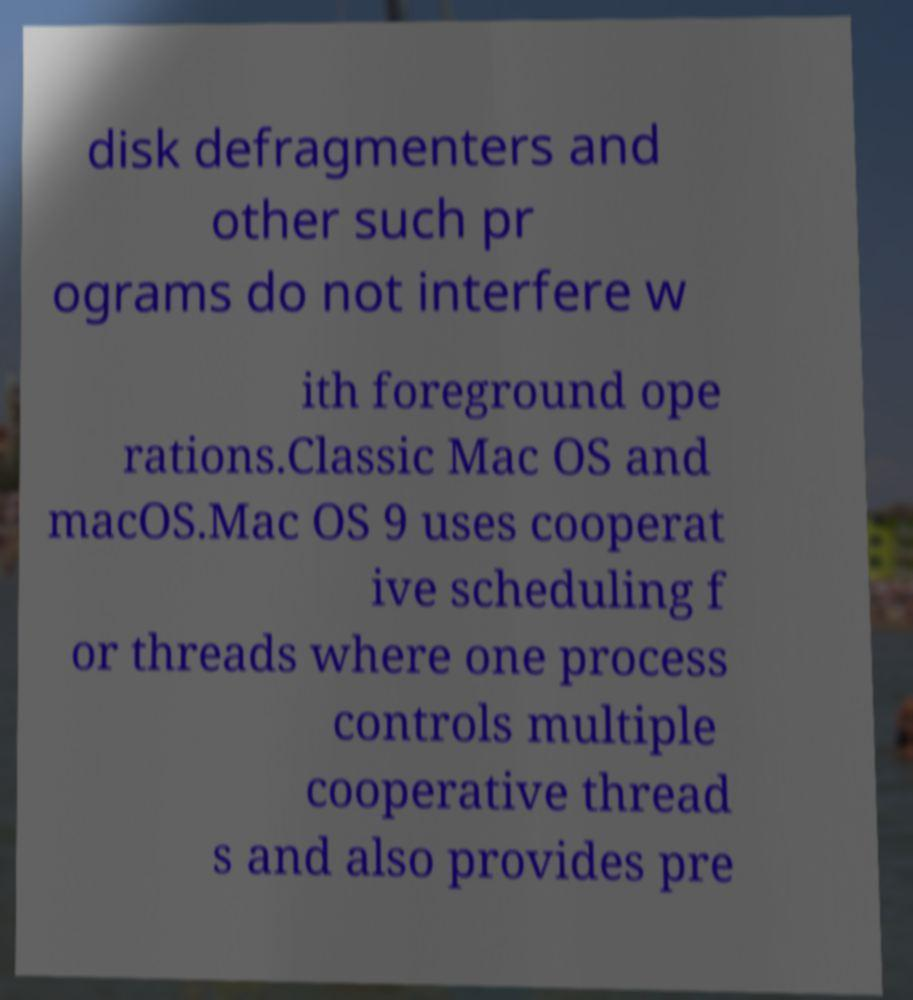Please identify and transcribe the text found in this image. disk defragmenters and other such pr ograms do not interfere w ith foreground ope rations.Classic Mac OS and macOS.Mac OS 9 uses cooperat ive scheduling f or threads where one process controls multiple cooperative thread s and also provides pre 